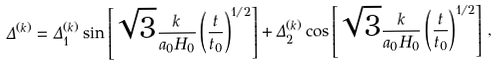<formula> <loc_0><loc_0><loc_500><loc_500>\Delta ^ { ( k ) } = \Delta _ { 1 } ^ { ( k ) } \sin \left [ \sqrt { 3 } \frac { k } { a _ { 0 } H _ { 0 } } \left ( \frac { t } { t _ { 0 } } \right ) ^ { 1 / 2 } \right ] + \Delta _ { 2 } ^ { ( k ) } \cos \left [ \sqrt { 3 } \frac { k } { a _ { 0 } H _ { 0 } } \left ( \frac { t } { t _ { 0 } } \right ) ^ { 1 / 2 } \right ] \, ,</formula> 